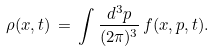Convert formula to latex. <formula><loc_0><loc_0><loc_500><loc_500>\rho ( { x } , t ) \, = \, \int \frac { d ^ { 3 } { p } } { ( 2 \pi ) ^ { 3 } } \, f ( { x } , { p } , t ) .</formula> 